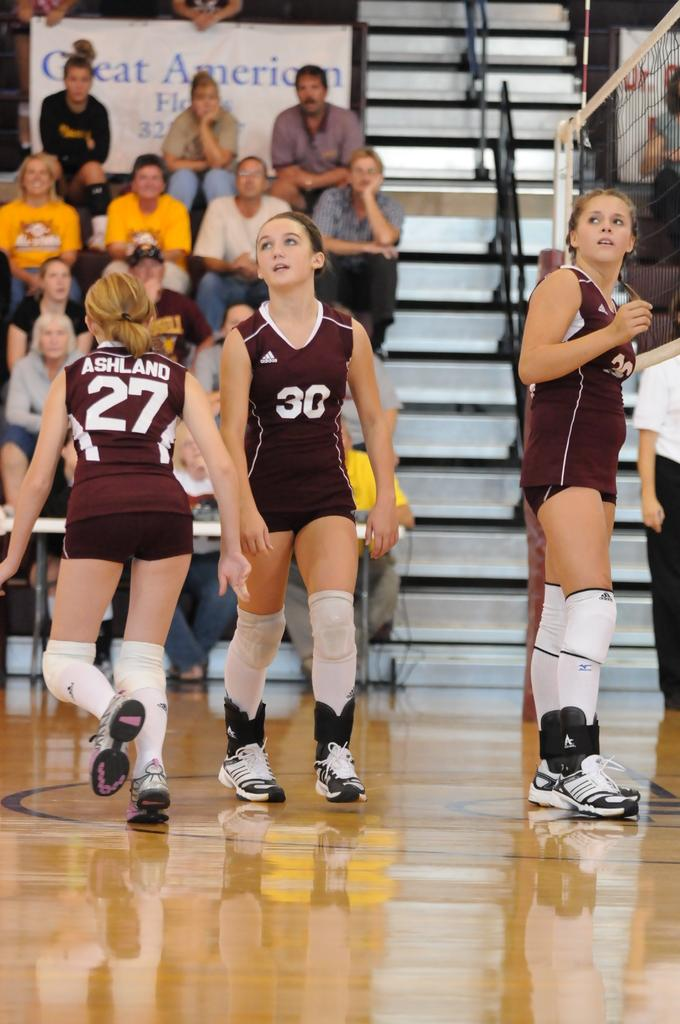What is happening on the surface in the image? There are people on the surface in the image. Can you describe the people in the background? There is a group of people sitting in the background. What architectural feature can be seen in the image? Stairs are visible in the image. What additional items are present in the image? Rods, banners, a net, and other objects are visible in the image. What type of turkey is being served to the sister in the image? There is no turkey or sister present in the image. How many geese are visible in the image? There are no geese visible in the image. 